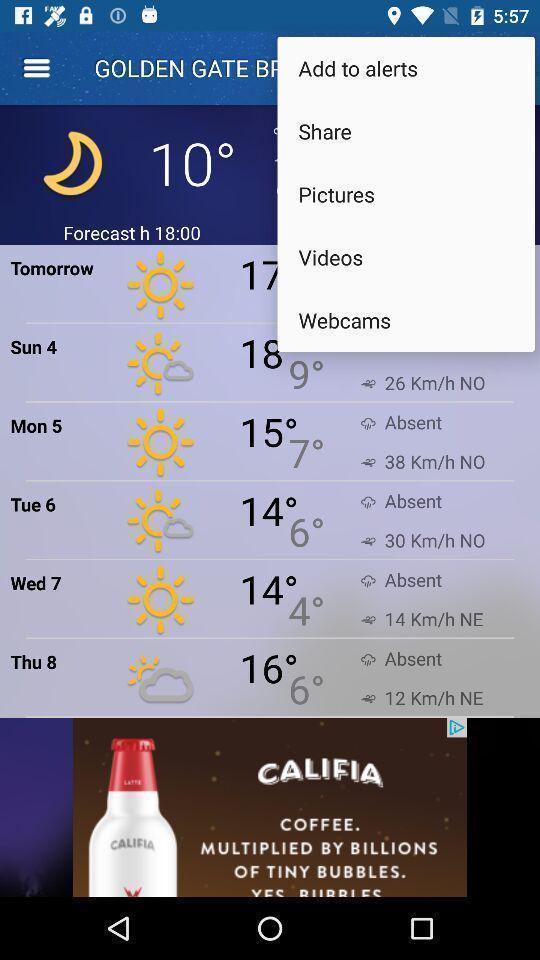Describe the content in this image. Pop up displaying various options for settings. 